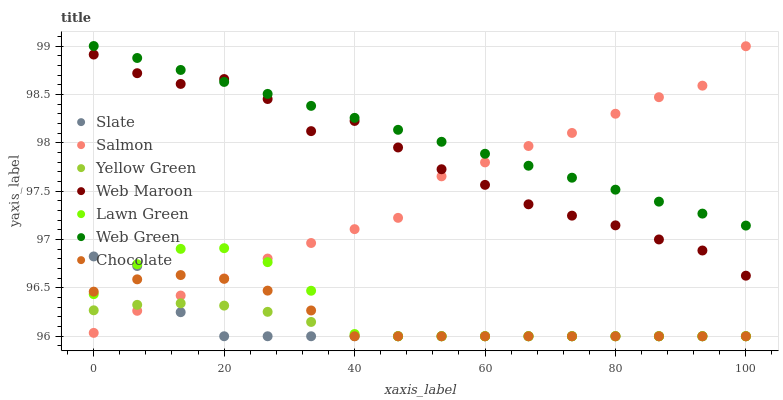Does Slate have the minimum area under the curve?
Answer yes or no. Yes. Does Web Green have the maximum area under the curve?
Answer yes or no. Yes. Does Yellow Green have the minimum area under the curve?
Answer yes or no. No. Does Yellow Green have the maximum area under the curve?
Answer yes or no. No. Is Web Green the smoothest?
Answer yes or no. Yes. Is Web Maroon the roughest?
Answer yes or no. Yes. Is Yellow Green the smoothest?
Answer yes or no. No. Is Yellow Green the roughest?
Answer yes or no. No. Does Lawn Green have the lowest value?
Answer yes or no. Yes. Does Salmon have the lowest value?
Answer yes or no. No. Does Web Green have the highest value?
Answer yes or no. Yes. Does Salmon have the highest value?
Answer yes or no. No. Is Lawn Green less than Web Maroon?
Answer yes or no. Yes. Is Web Green greater than Chocolate?
Answer yes or no. Yes. Does Web Maroon intersect Salmon?
Answer yes or no. Yes. Is Web Maroon less than Salmon?
Answer yes or no. No. Is Web Maroon greater than Salmon?
Answer yes or no. No. Does Lawn Green intersect Web Maroon?
Answer yes or no. No. 